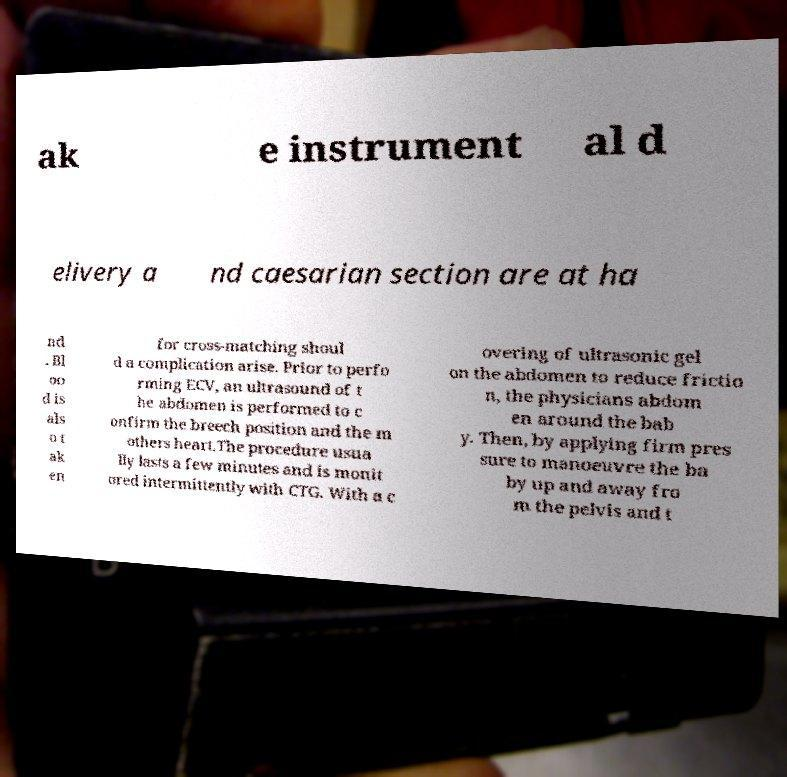I need the written content from this picture converted into text. Can you do that? ak e instrument al d elivery a nd caesarian section are at ha nd . Bl oo d is als o t ak en for cross-matching shoul d a complication arise. Prior to perfo rming ECV, an ultrasound of t he abdomen is performed to c onfirm the breech position and the m others heart.The procedure usua lly lasts a few minutes and is monit ored intermittently with CTG. With a c overing of ultrasonic gel on the abdomen to reduce frictio n, the physicians abdom en around the bab y. Then, by applying firm pres sure to manoeuvre the ba by up and away fro m the pelvis and t 